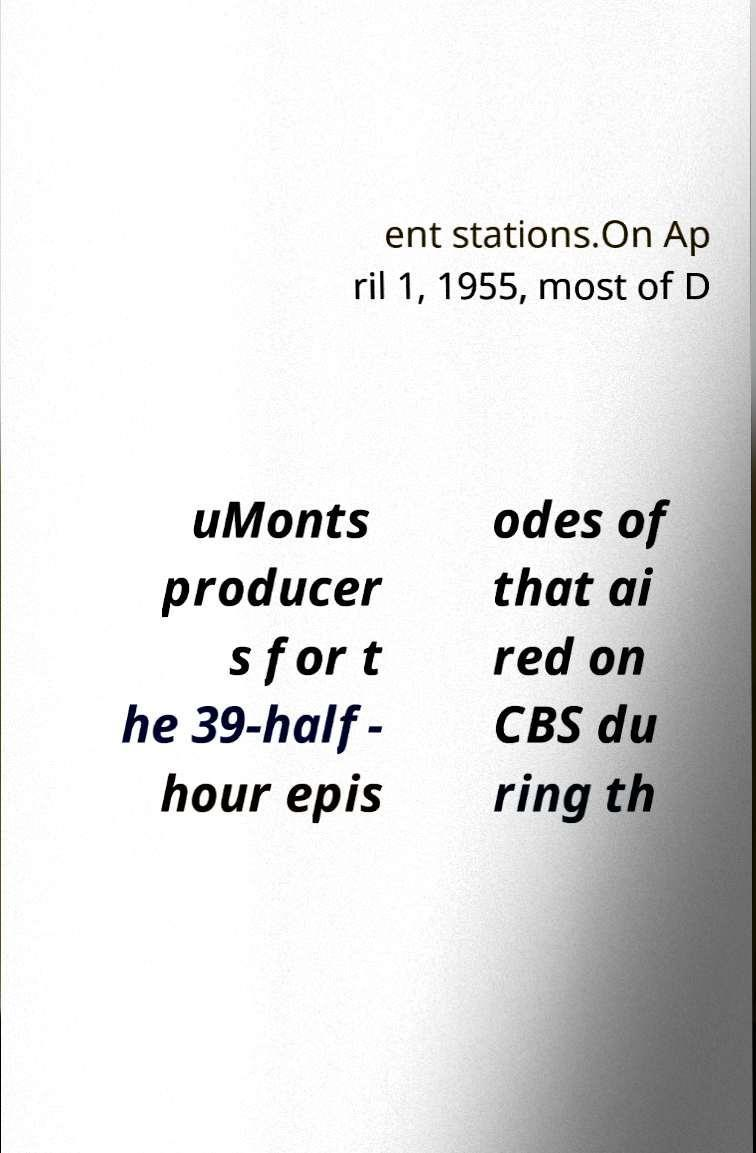I need the written content from this picture converted into text. Can you do that? ent stations.On Ap ril 1, 1955, most of D uMonts producer s for t he 39-half- hour epis odes of that ai red on CBS du ring th 